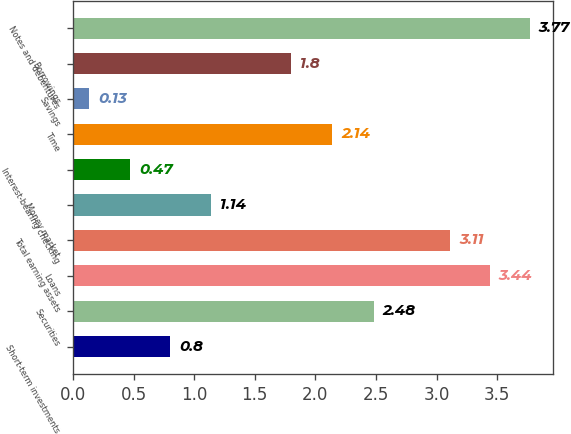Convert chart to OTSL. <chart><loc_0><loc_0><loc_500><loc_500><bar_chart><fcel>Short-term investments<fcel>Securities<fcel>Loans<fcel>Total earning assets<fcel>Money market<fcel>Interest-bearing checking<fcel>Time<fcel>Savings<fcel>Borrowings<fcel>Notes and debentures<nl><fcel>0.8<fcel>2.48<fcel>3.44<fcel>3.11<fcel>1.14<fcel>0.47<fcel>2.14<fcel>0.13<fcel>1.8<fcel>3.77<nl></chart> 